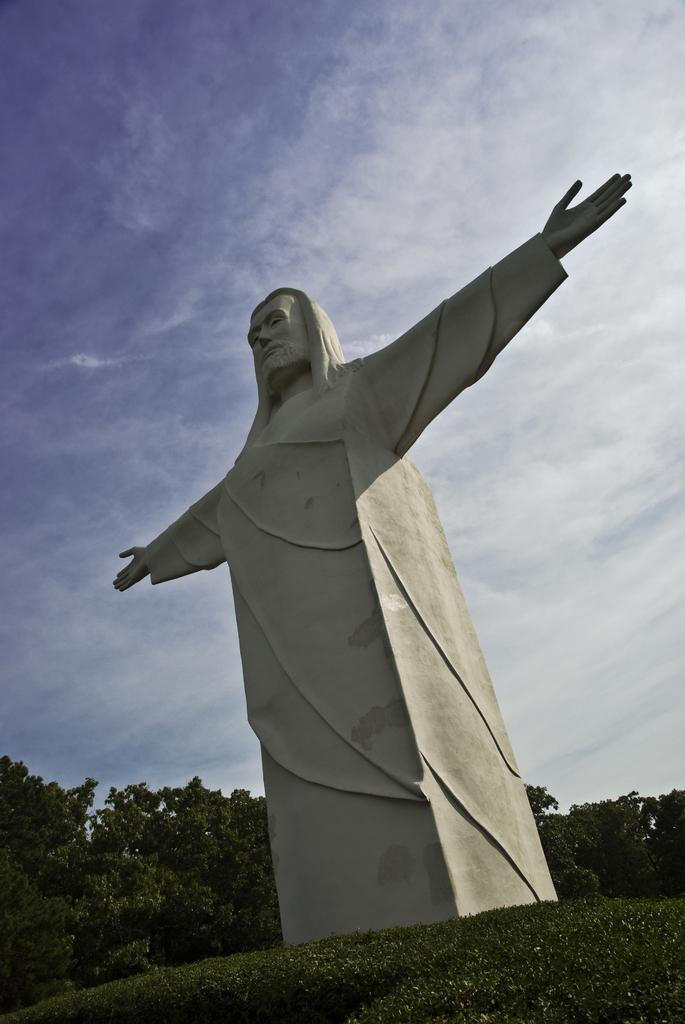What is the main subject in the front of the image? There is a statue in the front of the image. What type of vegetation is at the bottom of the image? There is grass at the bottom of the image. What can be seen in the background of the image? There are trees in the background of the image. What is visible at the top of the image? The sky is visible at the top of the image. What color is the crayon used to draw the statue in the image? There is no crayon or drawing present in the image; it is a photograph of a real statue. 